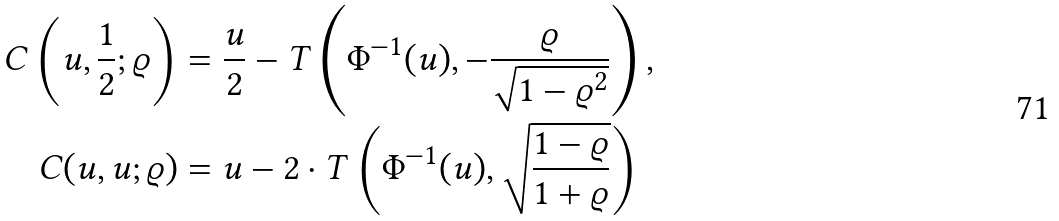Convert formula to latex. <formula><loc_0><loc_0><loc_500><loc_500>C \left ( u , \frac { 1 } { 2 } ; \varrho \right ) & = \frac { u } { 2 } - T \left ( \Phi ^ { - 1 } ( u ) , - \frac { \varrho } { \sqrt { 1 - \varrho ^ { 2 } } } \right ) , \\ C ( u , u ; \varrho ) & = u - 2 \cdot T \left ( \Phi ^ { - 1 } ( u ) , \sqrt { \frac { 1 - \varrho } { 1 + \varrho } } \right )</formula> 